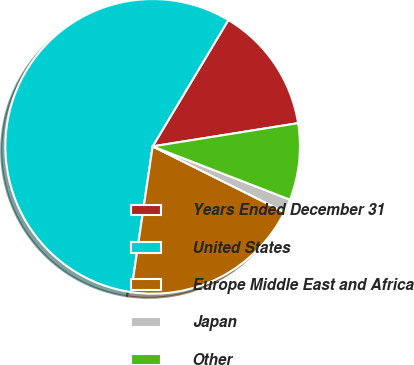Convert chart. <chart><loc_0><loc_0><loc_500><loc_500><pie_chart><fcel>Years Ended December 31<fcel>United States<fcel>Europe Middle East and Africa<fcel>Japan<fcel>Other<nl><fcel>13.89%<fcel>56.25%<fcel>19.97%<fcel>1.47%<fcel>8.41%<nl></chart> 